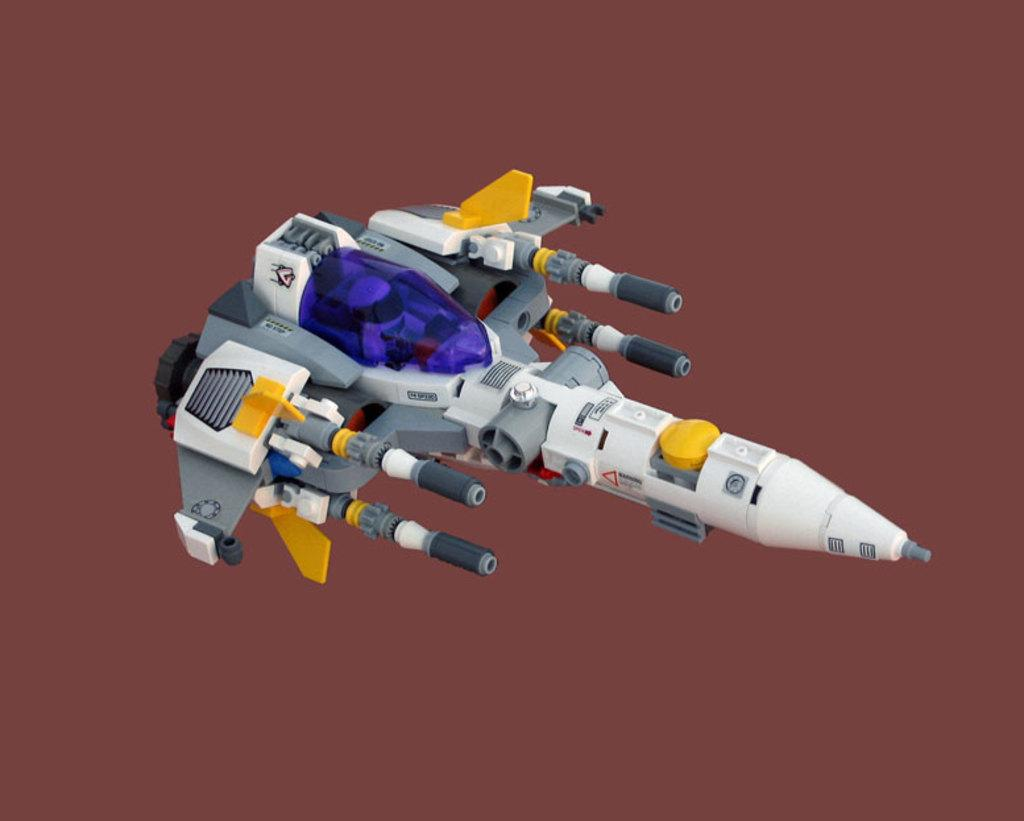What is the main subject of the picture? The main subject of the picture is a plane toy. Can you describe the colors of the plane toy? The plane toy has different colors. What color is the background of the image? The background of the image is in brown color. How many crates are stacked next to the plane toy in the image? There are no crates present in the image. What type of headgear is the plane toy wearing in the image? The plane toy is a toy and does not have a head or wear headgear. 